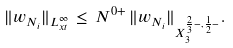<formula> <loc_0><loc_0><loc_500><loc_500>\| w _ { N _ { i } } \| _ { L ^ { \infty } _ { x t } } \, \leq \, N ^ { 0 + } \, \| w _ { N _ { i } } \| _ { X ^ { \frac { 2 } { 3 } - , \frac { 1 } { 2 } - } _ { 3 } } .</formula> 